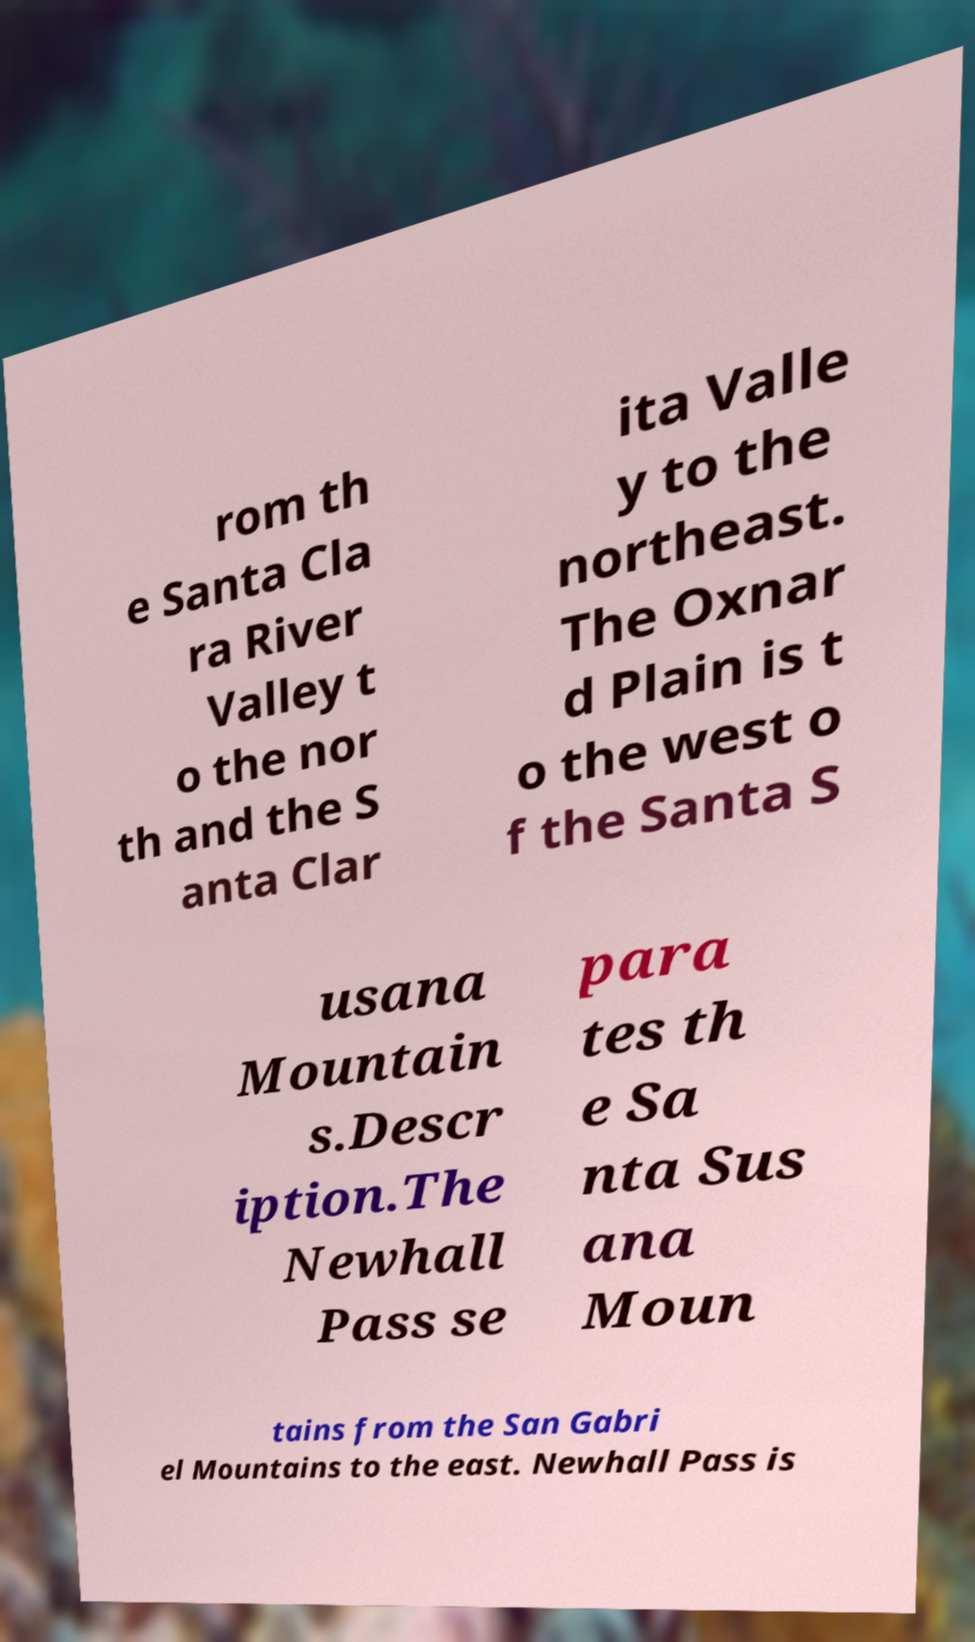Can you accurately transcribe the text from the provided image for me? rom th e Santa Cla ra River Valley t o the nor th and the S anta Clar ita Valle y to the northeast. The Oxnar d Plain is t o the west o f the Santa S usana Mountain s.Descr iption.The Newhall Pass se para tes th e Sa nta Sus ana Moun tains from the San Gabri el Mountains to the east. Newhall Pass is 